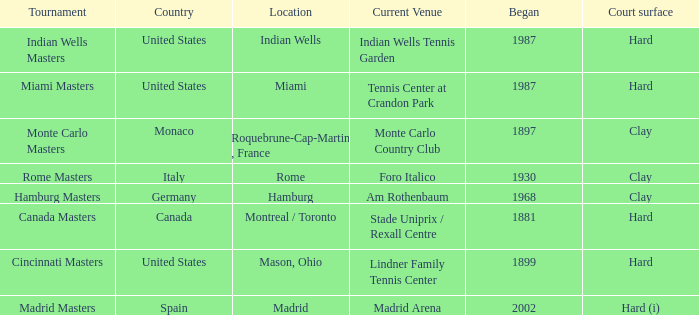Which tournaments current venue is the Madrid Arena? Madrid Masters. 